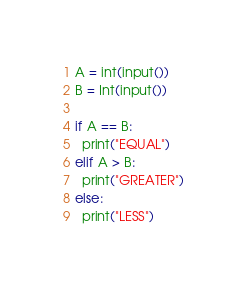<code> <loc_0><loc_0><loc_500><loc_500><_Python_>A = int(input())
B = Int(input())

if A == B:
  print("EQUAL")
elif A > B:
  print("GREATER")
else:
  print("LESS")</code> 